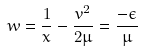<formula> <loc_0><loc_0><loc_500><loc_500>w = \frac { 1 } { x } - \frac { v ^ { 2 } } { 2 \mu } = \frac { - \epsilon } { \mu }</formula> 